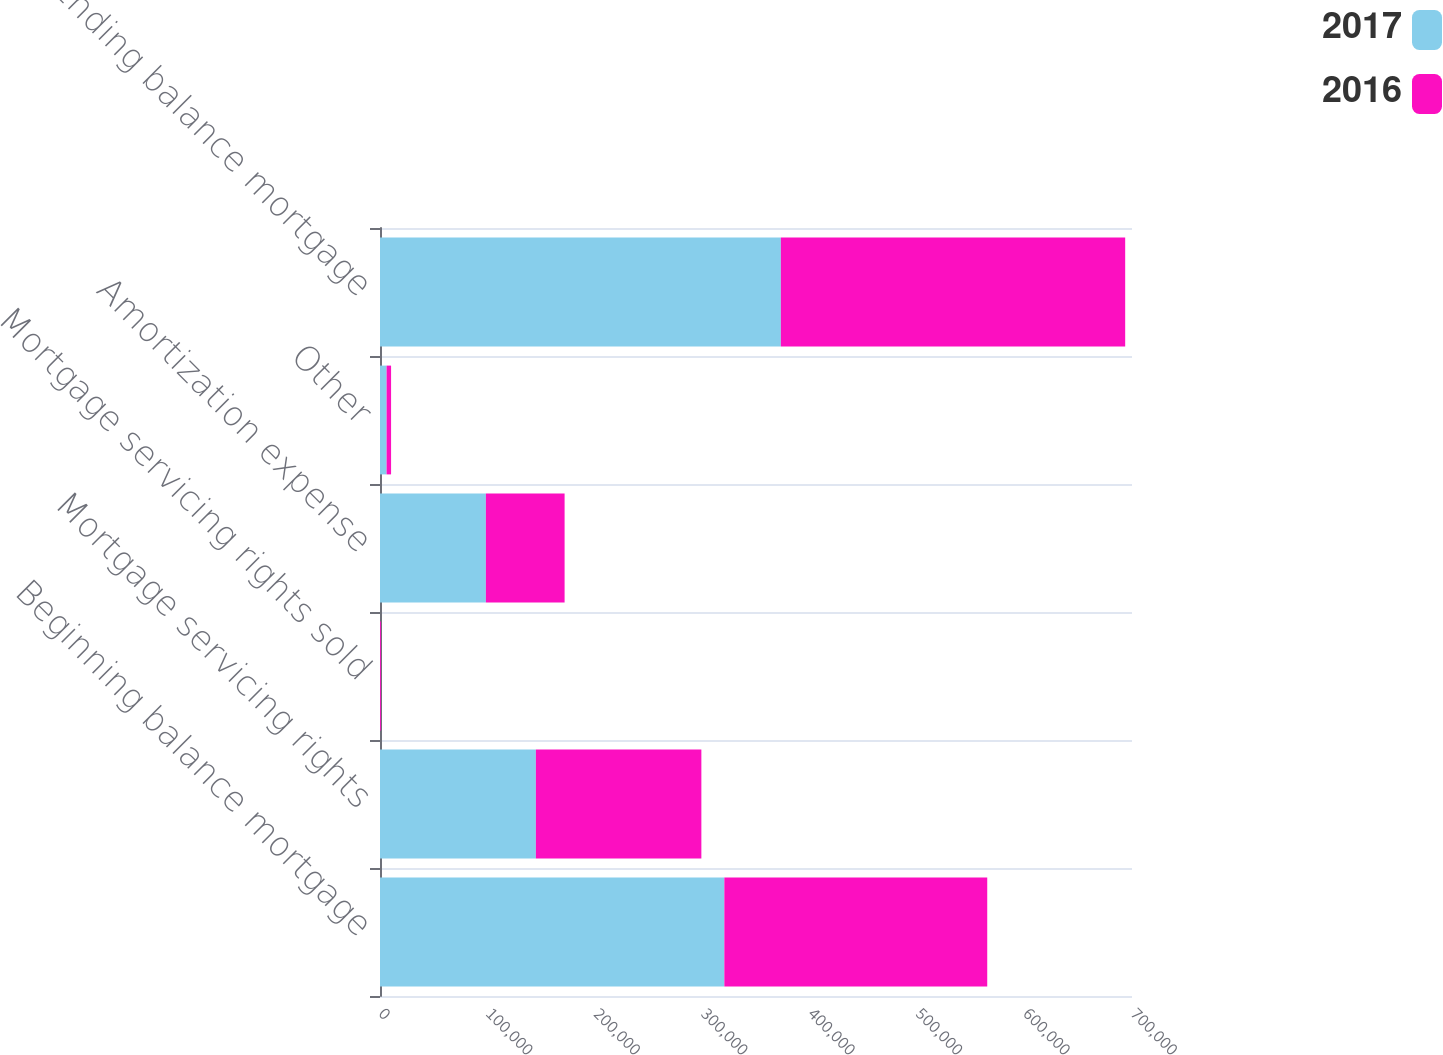<chart> <loc_0><loc_0><loc_500><loc_500><stacked_bar_chart><ecel><fcel>Beginning balance mortgage<fcel>Mortgage servicing rights<fcel>Mortgage servicing rights sold<fcel>Amortization expense<fcel>Other<fcel>Ending balance mortgage<nl><fcel>2017<fcel>320524<fcel>145103<fcel>71<fcel>98559<fcel>6134<fcel>373131<nl><fcel>2016<fcel>244723<fcel>154040<fcel>790<fcel>73273<fcel>4176<fcel>320524<nl></chart> 